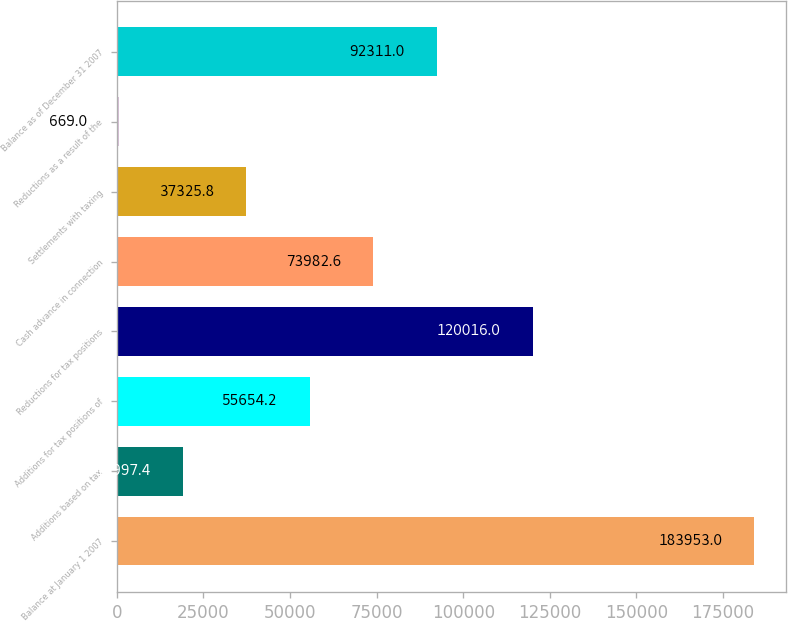Convert chart to OTSL. <chart><loc_0><loc_0><loc_500><loc_500><bar_chart><fcel>Balance at January 1 2007<fcel>Additions based on tax<fcel>Additions for tax positions of<fcel>Reductions for tax positions<fcel>Cash advance in connection<fcel>Settlements with taxing<fcel>Reductions as a result of the<fcel>Balance as of December 31 2007<nl><fcel>183953<fcel>18997.4<fcel>55654.2<fcel>120016<fcel>73982.6<fcel>37325.8<fcel>669<fcel>92311<nl></chart> 